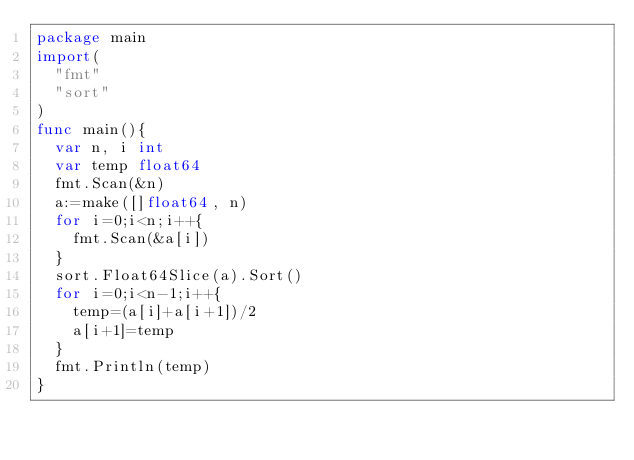<code> <loc_0><loc_0><loc_500><loc_500><_Go_>package main
import(
  "fmt"
  "sort"
)
func main(){
  var n, i int
  var temp float64
  fmt.Scan(&n)
  a:=make([]float64, n)
  for i=0;i<n;i++{
    fmt.Scan(&a[i])
  }
  sort.Float64Slice(a).Sort()
  for i=0;i<n-1;i++{
    temp=(a[i]+a[i+1])/2
    a[i+1]=temp
  }
  fmt.Println(temp)
}
</code> 